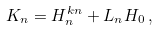Convert formula to latex. <formula><loc_0><loc_0><loc_500><loc_500>K _ { n } = H ^ { k n } _ { n } + L _ { n } H _ { 0 } \, ,</formula> 